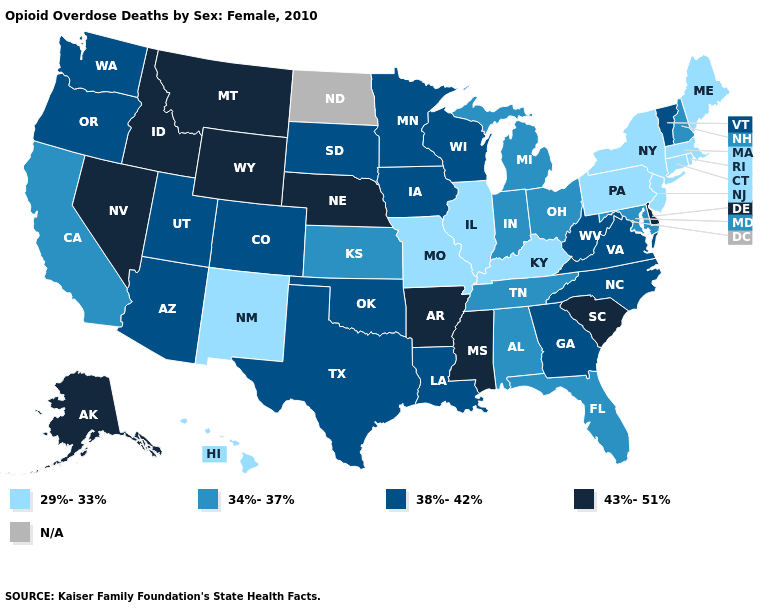Does the first symbol in the legend represent the smallest category?
Give a very brief answer. Yes. Does Idaho have the highest value in the West?
Be succinct. Yes. Is the legend a continuous bar?
Give a very brief answer. No. What is the lowest value in the West?
Keep it brief. 29%-33%. What is the value of California?
Give a very brief answer. 34%-37%. Is the legend a continuous bar?
Concise answer only. No. Name the states that have a value in the range N/A?
Quick response, please. North Dakota. Does Oklahoma have the highest value in the USA?
Give a very brief answer. No. What is the value of Louisiana?
Quick response, please. 38%-42%. Name the states that have a value in the range 38%-42%?
Short answer required. Arizona, Colorado, Georgia, Iowa, Louisiana, Minnesota, North Carolina, Oklahoma, Oregon, South Dakota, Texas, Utah, Vermont, Virginia, Washington, West Virginia, Wisconsin. Among the states that border Nevada , which have the highest value?
Quick response, please. Idaho. Name the states that have a value in the range 29%-33%?
Concise answer only. Connecticut, Hawaii, Illinois, Kentucky, Maine, Massachusetts, Missouri, New Jersey, New Mexico, New York, Pennsylvania, Rhode Island. What is the value of Iowa?
Give a very brief answer. 38%-42%. 